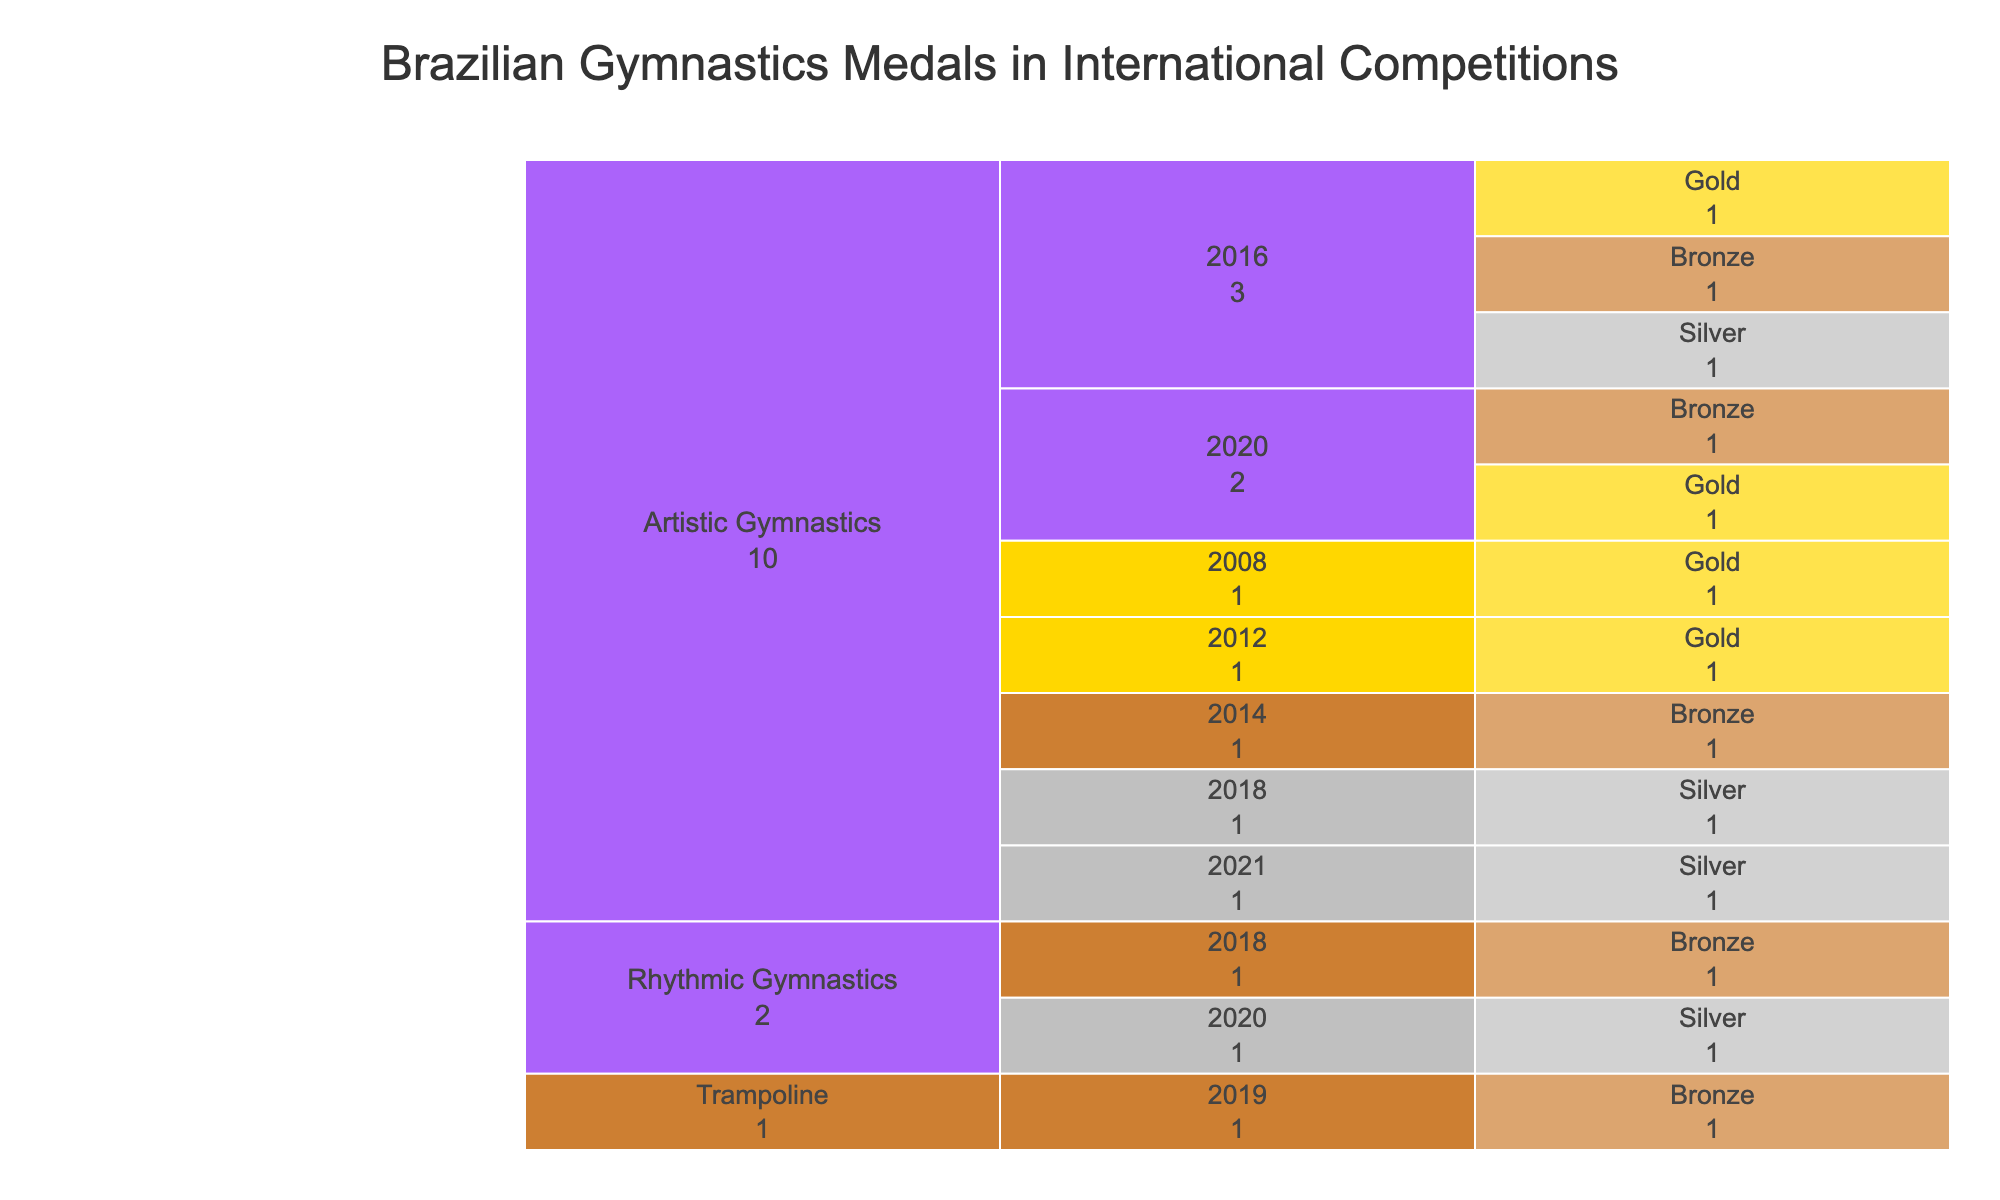How many gold medals did Brazilian gymnasts win in 2020? By locating the "Artistic Gymnastics" event in 2020 within the icicle chart, we can see the color representing gold. The count shows 1.
Answer: 1 Which event in 2016 had the most medals? For the year 2016, examine the branches under "Artistic Gymnastics." Summing up gold, silver, and bronze medals shows a total of 3 medals.
Answer: Artistic Gymnastics How many total medals has Arthur Zanetti won? By exploring the different branches for Arthur Zanetti's name, we find he won gold in 2012 and gold in 2016, summing to 2 medals.
Answer: 2 Which year had the highest number of medals in Artistic Gymnastics? Summing the medals in 2008 (1), 2012 (1), 2014 (1), 2016 (3), 2018 (1), 2020 (2), and 2021 (1), the year with the highest total is 2016, with 3 medals.
Answer: 2016 Compare the number of silver medals in Artistic Gymnastics vs. Rhythmic Gymnastics. Artistic Gymnastics has silver medals in 2016 (1), 2018 (1), and 2021 (1) for a total of 3. Rhythmic Gymnastics has one silver medal in 2020.
Answer: Artistic Gymnastics has more How many bronze medals were won in total across all events and years? Summing the bronze medals: Artistic Gymnastics (2014, 2016, 2018, 2020) has 4, Rhythmic Gymnastics (2018) has 1, and Trampoline (2019) has 1, totaling 6 bronze medals.
Answer: 6 In which event did Rebeca Andrade win a gold medal? By locating Rebeca Andrade's medals, we see she won a gold medal in Artistic Gymnastics in 2020.
Answer: Artistic Gymnastics How many medals did Brazil win in 2018 overall? Adding medals for 2018: Artistic Gymnastics has 1 silver and Rhythmic Gymnastics has 1 bronze, totaling 2 medals.
Answer: 2 Which event had the first recorded medal win according to the chart? The earliest year listed with a medal win is 2008 in Artistic Gymnastics, a gold medal.
Answer: Artistic Gymnastics Who won a bronze medal in Rhythmic Gymnastics? The icicle chart shows Bárbara Domingos winning a bronze medal in Rhythmic Gymnastics in 2018.
Answer: Bárbara Domingos 